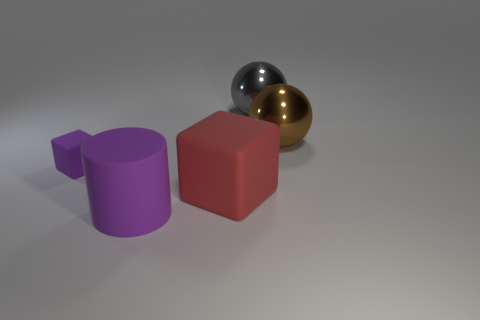Add 3 red matte cubes. How many objects exist? 8 Subtract all cylinders. How many objects are left? 4 Add 2 small matte blocks. How many small matte blocks are left? 3 Add 1 large shiny blocks. How many large shiny blocks exist? 1 Subtract 0 blue cubes. How many objects are left? 5 Subtract all tiny red rubber cubes. Subtract all large brown shiny things. How many objects are left? 4 